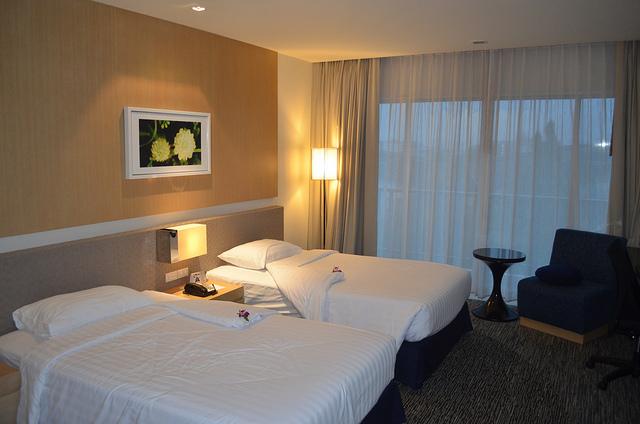What colors are the pillow?
Give a very brief answer. White. How many beds are in the room?
Short answer required. 2. How many pillows are there?
Be succinct. 2. How many beds?
Give a very brief answer. 2. What type of room is this?
Concise answer only. Hotel. What size is the bed?
Be succinct. Full. Is this indoors?
Be succinct. Yes. Is there central heating in this room?
Be succinct. Yes. 